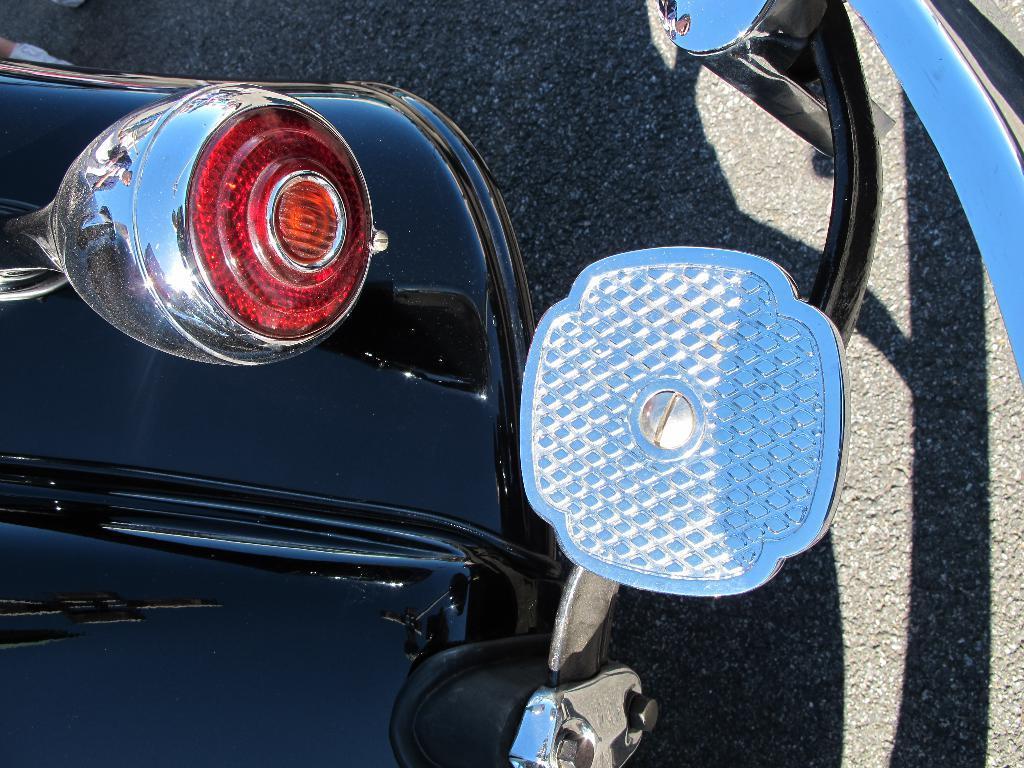Could you give a brief overview of what you see in this image? In this picture there is a vehicle. In the background it is road. On the left there is a light. 